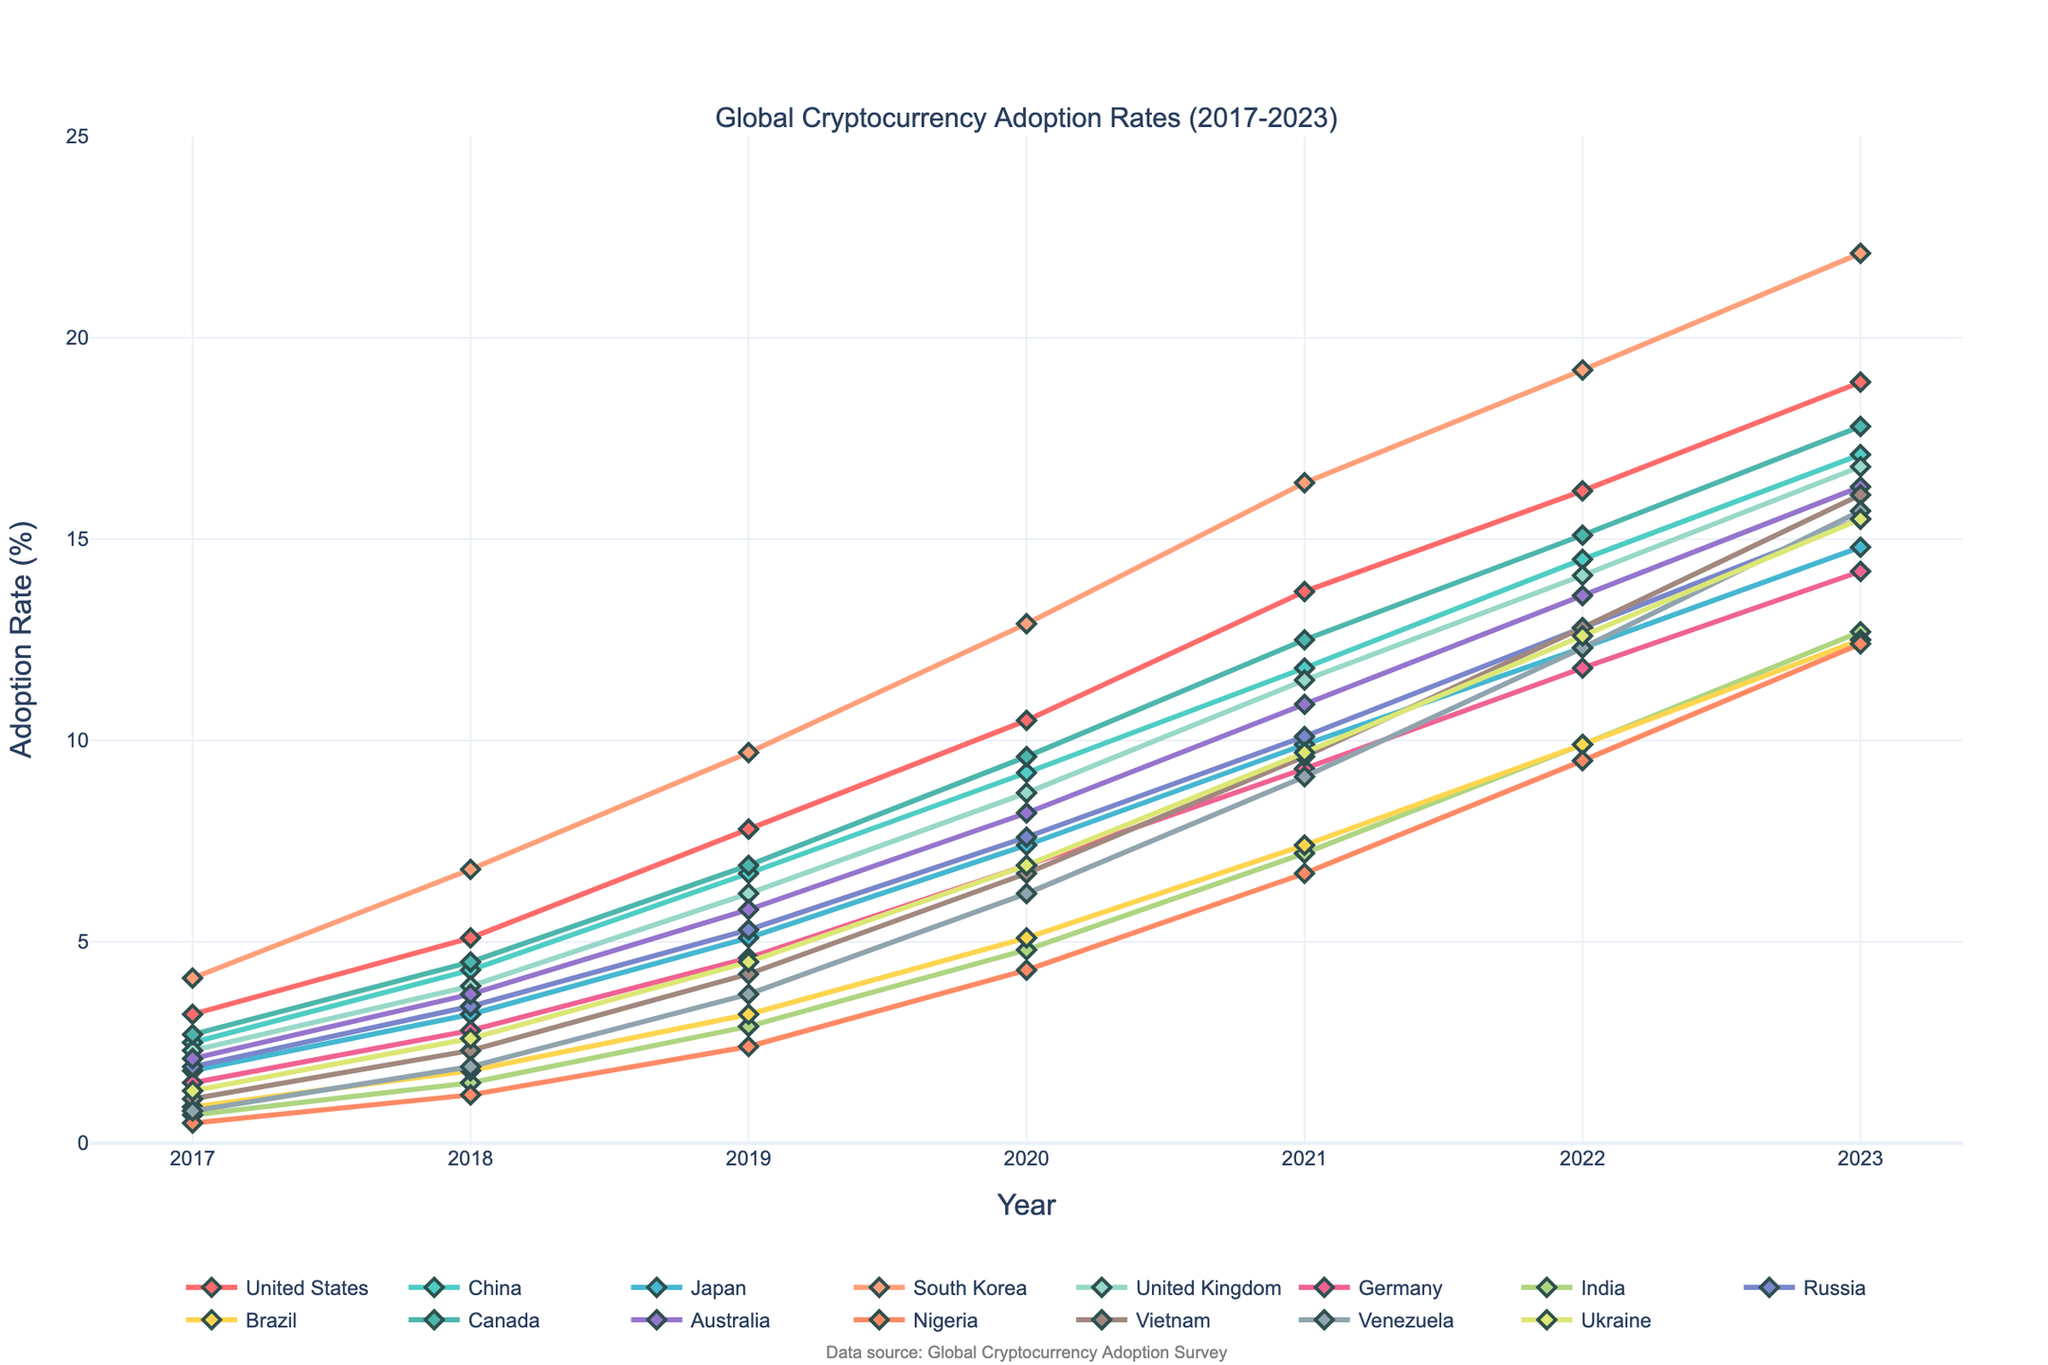What is the average cryptocurrency adoption rate in the United States from 2017 to 2023? To find the average adoption rate, add the adoption rates from 2017 to 2023 and divide by the number of years. The rates are (3.2 + 5.1 + 7.8 + 10.5 + 13.7 + 16.2 + 18.9) = 75.4. Divide by 7 years, so the average is 75.4 / 7 = 10.77
Answer: 10.77 Which country had the highest cryptocurrency adoption rate in 2023? Check the adoption rates for all countries in 2023. The highest value is 22.1 in South Korea.
Answer: South Korea By how many percentage points did the cryptocurrency adoption rate in China increase from 2017 to 2023? Subtract the 2017 adoption rate (2.5) from the 2023 adoption rate (17.1). The increase is 17.1 - 2.5 = 14.6 percentage points.
Answer: 14.6 Which country had the lowest adoption rate in 2017, and what was the rate? Look at the adoption rates in 2017 for all countries. The lowest value is 0.5 in Nigeria.
Answer: Nigeria, 0.5 Compare the adoption rate of Brazil in 2021 with that of Germany in 2021. Which is higher, and by how much? The adoption rate for Brazil in 2021 is 7.4, and for Germany, it is 9.3. Germany's rate is higher by 9.3 - 7.4 = 1.9 percentage points.
Answer: Germany, 1.9 Which countries have seen their adoption rate more than double from 2017 to 2023? Check each country's adoption rate in 2017 and 2023. If the 2023 rate is more than twice the 2017 rate, the country qualifies. For example, United States: 3.2 in 2017 to 18.9 in 2023 (yes), China: 2.5 to 17.1 (yes), and so forth. The countries that qualify are: United States, China, Japan, South Korea, United Kingdom, Germany, Brazil, Canada, Nigeria, and Vietnam.
Answer: United States, China, Japan, South Korea, United Kingdom, Germany, Brazil, Canada, Nigeria, Vietnam What is the median adoption rate for 2023 across all countries? List the 2023 adoption rates in ascending order: [12.4, 12.5, 12.7, 14.2, 14.8, 15.5, 15.5, 16.1, 16.3, 16.8, 17.1, 17.8, 18.9, 22.1]. With 14 data points, the median is the average of the 7th and 8th values: (15.5 + 15.5) / 2 = 15.5.
Answer: 15.5 By how many percentage points did the adoption rate in India increase from 2019 to 2020? Subtract the 2019 rate (2.9) from the 2020 rate (4.8). The increase is 4.8 - 2.9 = 1.9 percentage points.
Answer: 1.9 Which country had a faster growth rate in adoption from 2017 to 2020, Vietnam or Venezuela? Calculate the growth rate for both countries: Vietnam's increase is 6.7 - 1.1 = 5.6 percentage points; Venezuela's increase is 6.2 - 0.8 = 5.4 percentage points. Vietnam had a faster growth rate by 5.6 - 5.4 = 0.2 percentage points.
Answer: Vietnam What is the difference in cryptocurrency adoption rates between the United Kingdom and Nigeria in 2023? Subtract Nigeria’s 2023 rate (12.4) from the United Kingdom's 2023 rate (16.8). The difference is 16.8 - 12.4 = 4.4 percentage points.
Answer: 4.4 